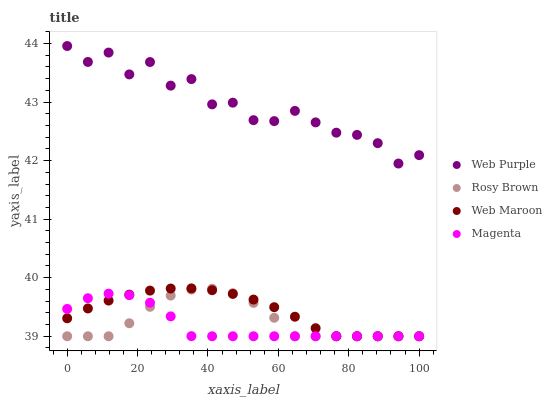Does Magenta have the minimum area under the curve?
Answer yes or no. Yes. Does Web Purple have the maximum area under the curve?
Answer yes or no. Yes. Does Rosy Brown have the minimum area under the curve?
Answer yes or no. No. Does Rosy Brown have the maximum area under the curve?
Answer yes or no. No. Is Web Maroon the smoothest?
Answer yes or no. Yes. Is Web Purple the roughest?
Answer yes or no. Yes. Is Rosy Brown the smoothest?
Answer yes or no. No. Is Rosy Brown the roughest?
Answer yes or no. No. Does Rosy Brown have the lowest value?
Answer yes or no. Yes. Does Web Purple have the highest value?
Answer yes or no. Yes. Does Rosy Brown have the highest value?
Answer yes or no. No. Is Rosy Brown less than Web Purple?
Answer yes or no. Yes. Is Web Purple greater than Web Maroon?
Answer yes or no. Yes. Does Magenta intersect Rosy Brown?
Answer yes or no. Yes. Is Magenta less than Rosy Brown?
Answer yes or no. No. Is Magenta greater than Rosy Brown?
Answer yes or no. No. Does Rosy Brown intersect Web Purple?
Answer yes or no. No. 